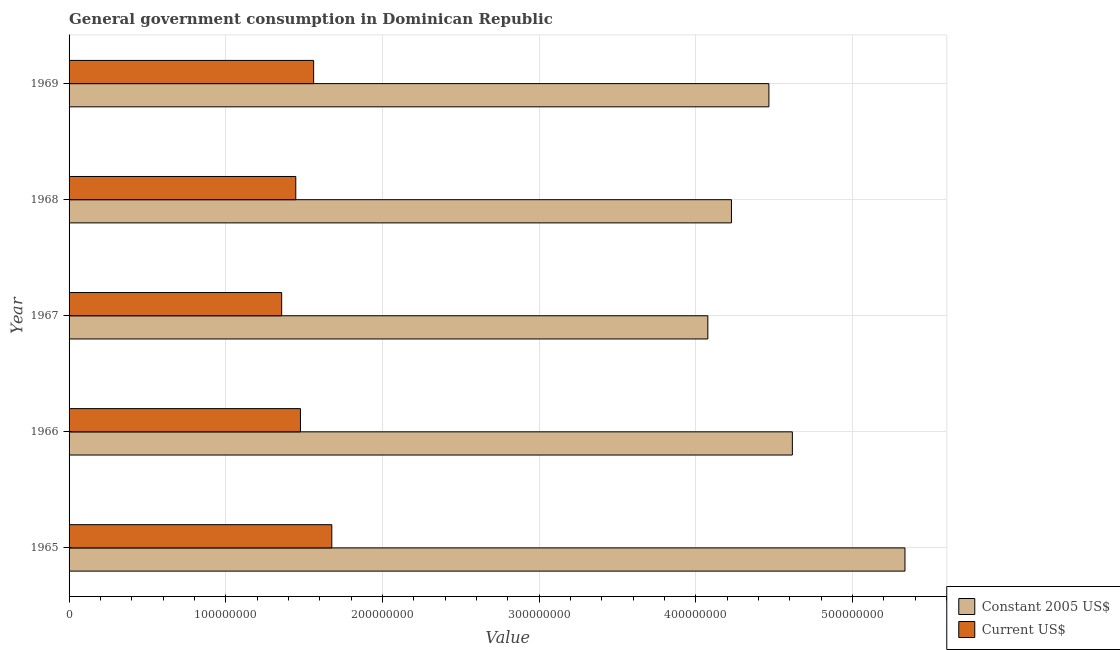How many different coloured bars are there?
Provide a succinct answer. 2. Are the number of bars on each tick of the Y-axis equal?
Keep it short and to the point. Yes. How many bars are there on the 3rd tick from the bottom?
Offer a terse response. 2. What is the label of the 3rd group of bars from the top?
Your answer should be very brief. 1967. In how many cases, is the number of bars for a given year not equal to the number of legend labels?
Give a very brief answer. 0. What is the value consumed in constant 2005 us$ in 1965?
Offer a very short reply. 5.34e+08. Across all years, what is the maximum value consumed in current us$?
Keep it short and to the point. 1.68e+08. Across all years, what is the minimum value consumed in constant 2005 us$?
Offer a terse response. 4.08e+08. In which year was the value consumed in constant 2005 us$ maximum?
Provide a short and direct response. 1965. In which year was the value consumed in constant 2005 us$ minimum?
Ensure brevity in your answer.  1967. What is the total value consumed in constant 2005 us$ in the graph?
Make the answer very short. 2.27e+09. What is the difference between the value consumed in constant 2005 us$ in 1965 and that in 1968?
Keep it short and to the point. 1.11e+08. What is the difference between the value consumed in constant 2005 us$ in 1969 and the value consumed in current us$ in 1968?
Offer a very short reply. 3.02e+08. What is the average value consumed in constant 2005 us$ per year?
Your response must be concise. 4.54e+08. In the year 1969, what is the difference between the value consumed in current us$ and value consumed in constant 2005 us$?
Provide a succinct answer. -2.91e+08. In how many years, is the value consumed in current us$ greater than 300000000 ?
Keep it short and to the point. 0. What is the ratio of the value consumed in constant 2005 us$ in 1966 to that in 1968?
Provide a succinct answer. 1.09. Is the value consumed in current us$ in 1965 less than that in 1966?
Provide a short and direct response. No. Is the difference between the value consumed in constant 2005 us$ in 1968 and 1969 greater than the difference between the value consumed in current us$ in 1968 and 1969?
Give a very brief answer. No. What is the difference between the highest and the second highest value consumed in current us$?
Give a very brief answer. 1.16e+07. What is the difference between the highest and the lowest value consumed in current us$?
Your response must be concise. 3.20e+07. What does the 2nd bar from the top in 1967 represents?
Offer a very short reply. Constant 2005 US$. What does the 2nd bar from the bottom in 1966 represents?
Offer a terse response. Current US$. How many years are there in the graph?
Your answer should be compact. 5. What is the difference between two consecutive major ticks on the X-axis?
Offer a very short reply. 1.00e+08. Are the values on the major ticks of X-axis written in scientific E-notation?
Your answer should be very brief. No. Does the graph contain any zero values?
Ensure brevity in your answer.  No. Where does the legend appear in the graph?
Make the answer very short. Bottom right. What is the title of the graph?
Give a very brief answer. General government consumption in Dominican Republic. Does "Non-pregnant women" appear as one of the legend labels in the graph?
Offer a terse response. No. What is the label or title of the X-axis?
Your response must be concise. Value. What is the label or title of the Y-axis?
Your answer should be compact. Year. What is the Value of Constant 2005 US$ in 1965?
Provide a short and direct response. 5.34e+08. What is the Value in Current US$ in 1965?
Ensure brevity in your answer.  1.68e+08. What is the Value of Constant 2005 US$ in 1966?
Ensure brevity in your answer.  4.62e+08. What is the Value of Current US$ in 1966?
Offer a terse response. 1.48e+08. What is the Value in Constant 2005 US$ in 1967?
Offer a terse response. 4.08e+08. What is the Value in Current US$ in 1967?
Your answer should be compact. 1.36e+08. What is the Value of Constant 2005 US$ in 1968?
Provide a short and direct response. 4.23e+08. What is the Value of Current US$ in 1968?
Your answer should be very brief. 1.45e+08. What is the Value of Constant 2005 US$ in 1969?
Your response must be concise. 4.47e+08. What is the Value of Current US$ in 1969?
Provide a short and direct response. 1.56e+08. Across all years, what is the maximum Value in Constant 2005 US$?
Ensure brevity in your answer.  5.34e+08. Across all years, what is the maximum Value in Current US$?
Ensure brevity in your answer.  1.68e+08. Across all years, what is the minimum Value in Constant 2005 US$?
Provide a succinct answer. 4.08e+08. Across all years, what is the minimum Value of Current US$?
Your answer should be compact. 1.36e+08. What is the total Value in Constant 2005 US$ in the graph?
Your answer should be very brief. 2.27e+09. What is the total Value in Current US$ in the graph?
Provide a short and direct response. 7.52e+08. What is the difference between the Value in Constant 2005 US$ in 1965 and that in 1966?
Provide a succinct answer. 7.19e+07. What is the difference between the Value in Current US$ in 1965 and that in 1966?
Offer a very short reply. 2.00e+07. What is the difference between the Value of Constant 2005 US$ in 1965 and that in 1967?
Provide a succinct answer. 1.26e+08. What is the difference between the Value in Current US$ in 1965 and that in 1967?
Your answer should be compact. 3.20e+07. What is the difference between the Value of Constant 2005 US$ in 1965 and that in 1968?
Your answer should be compact. 1.11e+08. What is the difference between the Value in Current US$ in 1965 and that in 1968?
Your answer should be compact. 2.30e+07. What is the difference between the Value in Constant 2005 US$ in 1965 and that in 1969?
Provide a short and direct response. 8.68e+07. What is the difference between the Value of Current US$ in 1965 and that in 1969?
Provide a short and direct response. 1.16e+07. What is the difference between the Value in Constant 2005 US$ in 1966 and that in 1967?
Ensure brevity in your answer.  5.39e+07. What is the difference between the Value of Current US$ in 1966 and that in 1967?
Your response must be concise. 1.20e+07. What is the difference between the Value in Constant 2005 US$ in 1966 and that in 1968?
Make the answer very short. 3.89e+07. What is the difference between the Value in Constant 2005 US$ in 1966 and that in 1969?
Give a very brief answer. 1.50e+07. What is the difference between the Value in Current US$ in 1966 and that in 1969?
Ensure brevity in your answer.  -8.40e+06. What is the difference between the Value of Constant 2005 US$ in 1967 and that in 1968?
Make the answer very short. -1.51e+07. What is the difference between the Value of Current US$ in 1967 and that in 1968?
Make the answer very short. -9.00e+06. What is the difference between the Value of Constant 2005 US$ in 1967 and that in 1969?
Give a very brief answer. -3.90e+07. What is the difference between the Value in Current US$ in 1967 and that in 1969?
Your response must be concise. -2.04e+07. What is the difference between the Value in Constant 2005 US$ in 1968 and that in 1969?
Keep it short and to the point. -2.39e+07. What is the difference between the Value of Current US$ in 1968 and that in 1969?
Your response must be concise. -1.14e+07. What is the difference between the Value of Constant 2005 US$ in 1965 and the Value of Current US$ in 1966?
Your response must be concise. 3.86e+08. What is the difference between the Value in Constant 2005 US$ in 1965 and the Value in Current US$ in 1967?
Give a very brief answer. 3.98e+08. What is the difference between the Value of Constant 2005 US$ in 1965 and the Value of Current US$ in 1968?
Offer a very short reply. 3.89e+08. What is the difference between the Value in Constant 2005 US$ in 1965 and the Value in Current US$ in 1969?
Ensure brevity in your answer.  3.77e+08. What is the difference between the Value of Constant 2005 US$ in 1966 and the Value of Current US$ in 1967?
Give a very brief answer. 3.26e+08. What is the difference between the Value of Constant 2005 US$ in 1966 and the Value of Current US$ in 1968?
Provide a succinct answer. 3.17e+08. What is the difference between the Value in Constant 2005 US$ in 1966 and the Value in Current US$ in 1969?
Give a very brief answer. 3.06e+08. What is the difference between the Value in Constant 2005 US$ in 1967 and the Value in Current US$ in 1968?
Keep it short and to the point. 2.63e+08. What is the difference between the Value of Constant 2005 US$ in 1967 and the Value of Current US$ in 1969?
Give a very brief answer. 2.52e+08. What is the difference between the Value in Constant 2005 US$ in 1968 and the Value in Current US$ in 1969?
Provide a short and direct response. 2.67e+08. What is the average Value of Constant 2005 US$ per year?
Offer a very short reply. 4.54e+08. What is the average Value in Current US$ per year?
Offer a very short reply. 1.50e+08. In the year 1965, what is the difference between the Value in Constant 2005 US$ and Value in Current US$?
Offer a terse response. 3.66e+08. In the year 1966, what is the difference between the Value of Constant 2005 US$ and Value of Current US$?
Make the answer very short. 3.14e+08. In the year 1967, what is the difference between the Value in Constant 2005 US$ and Value in Current US$?
Your response must be concise. 2.72e+08. In the year 1968, what is the difference between the Value of Constant 2005 US$ and Value of Current US$?
Provide a short and direct response. 2.78e+08. In the year 1969, what is the difference between the Value in Constant 2005 US$ and Value in Current US$?
Your response must be concise. 2.91e+08. What is the ratio of the Value in Constant 2005 US$ in 1965 to that in 1966?
Give a very brief answer. 1.16. What is the ratio of the Value in Current US$ in 1965 to that in 1966?
Ensure brevity in your answer.  1.14. What is the ratio of the Value in Constant 2005 US$ in 1965 to that in 1967?
Give a very brief answer. 1.31. What is the ratio of the Value in Current US$ in 1965 to that in 1967?
Your answer should be very brief. 1.24. What is the ratio of the Value in Constant 2005 US$ in 1965 to that in 1968?
Provide a succinct answer. 1.26. What is the ratio of the Value of Current US$ in 1965 to that in 1968?
Keep it short and to the point. 1.16. What is the ratio of the Value in Constant 2005 US$ in 1965 to that in 1969?
Keep it short and to the point. 1.19. What is the ratio of the Value in Current US$ in 1965 to that in 1969?
Give a very brief answer. 1.07. What is the ratio of the Value of Constant 2005 US$ in 1966 to that in 1967?
Provide a succinct answer. 1.13. What is the ratio of the Value in Current US$ in 1966 to that in 1967?
Make the answer very short. 1.09. What is the ratio of the Value of Constant 2005 US$ in 1966 to that in 1968?
Give a very brief answer. 1.09. What is the ratio of the Value of Current US$ in 1966 to that in 1968?
Offer a very short reply. 1.02. What is the ratio of the Value of Constant 2005 US$ in 1966 to that in 1969?
Your answer should be compact. 1.03. What is the ratio of the Value of Current US$ in 1966 to that in 1969?
Your response must be concise. 0.95. What is the ratio of the Value of Current US$ in 1967 to that in 1968?
Ensure brevity in your answer.  0.94. What is the ratio of the Value of Constant 2005 US$ in 1967 to that in 1969?
Ensure brevity in your answer.  0.91. What is the ratio of the Value of Current US$ in 1967 to that in 1969?
Keep it short and to the point. 0.87. What is the ratio of the Value of Constant 2005 US$ in 1968 to that in 1969?
Provide a short and direct response. 0.95. What is the ratio of the Value of Current US$ in 1968 to that in 1969?
Provide a succinct answer. 0.93. What is the difference between the highest and the second highest Value in Constant 2005 US$?
Provide a short and direct response. 7.19e+07. What is the difference between the highest and the second highest Value in Current US$?
Give a very brief answer. 1.16e+07. What is the difference between the highest and the lowest Value of Constant 2005 US$?
Your answer should be compact. 1.26e+08. What is the difference between the highest and the lowest Value of Current US$?
Provide a short and direct response. 3.20e+07. 